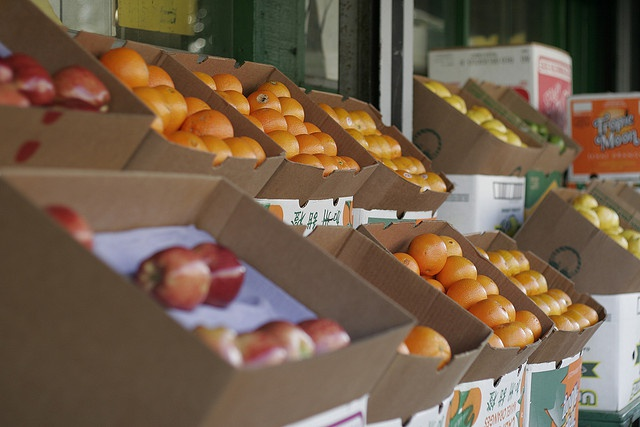Describe the objects in this image and their specific colors. I can see orange in black, red, maroon, and gray tones, orange in black, red, tan, and maroon tones, apple in black, maroon, and brown tones, orange in black, olive, maroon, and tan tones, and apple in black, brown, and maroon tones in this image. 